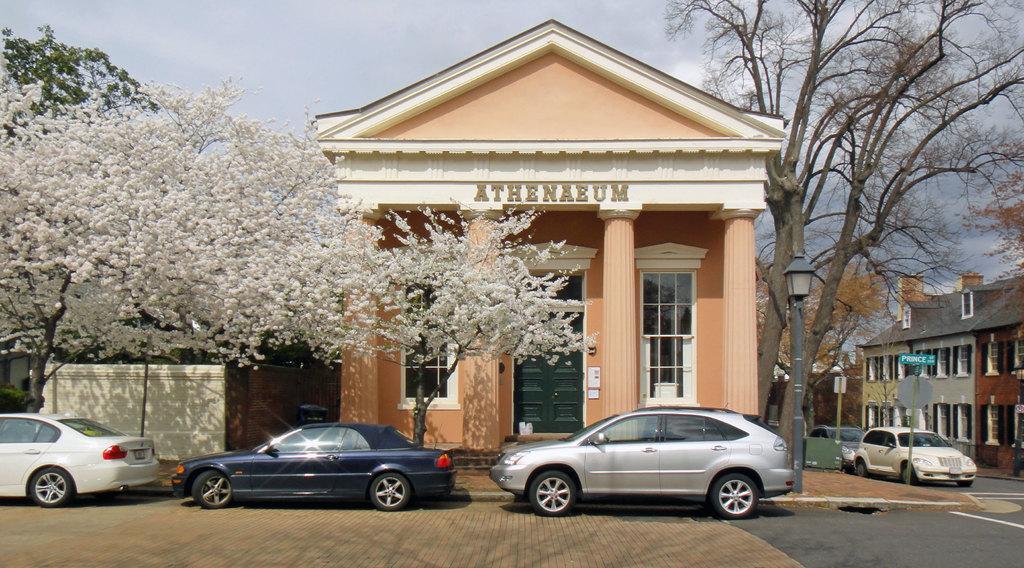How would you summarize this image in a sentence or two? In this picture we can observe an orange color building. There are white color trees on the left side. We can observe three cars parked in front of this house. On the right side there are some buildings and trees. In the background there is a sky. 